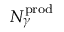<formula> <loc_0><loc_0><loc_500><loc_500>N _ { \gamma } ^ { p r o d }</formula> 